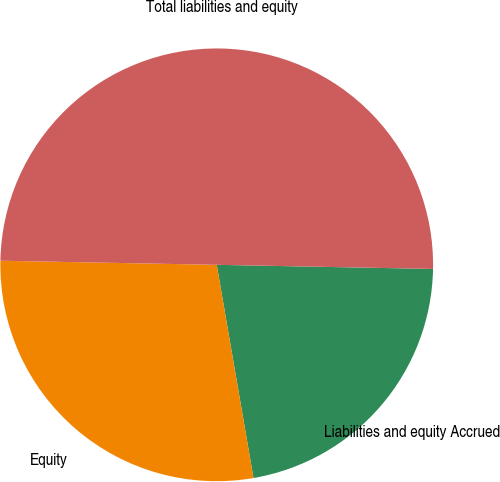Convert chart. <chart><loc_0><loc_0><loc_500><loc_500><pie_chart><fcel>Liabilities and equity Accrued<fcel>Equity<fcel>Total liabilities and equity<nl><fcel>21.98%<fcel>28.02%<fcel>50.0%<nl></chart> 